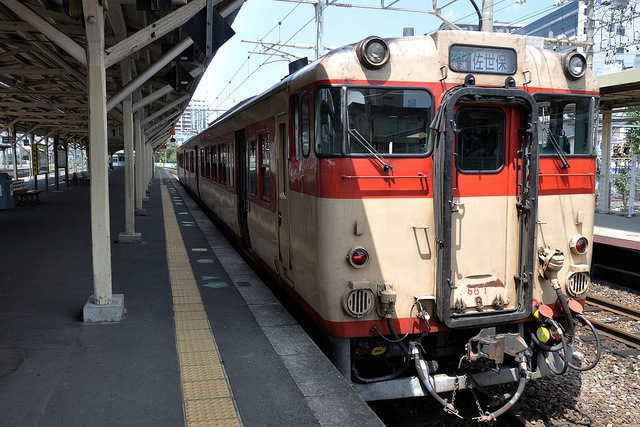Describe the objects in this image and their specific colors. I can see train in black, ivory, gray, and maroon tones and bench in black and gray tones in this image. 